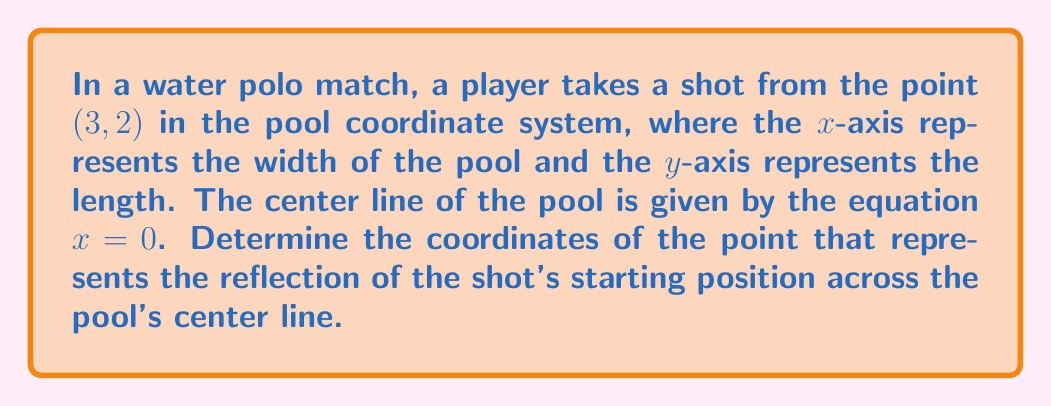What is the answer to this math problem? To solve this problem, we need to understand the concept of reflection across a vertical line. In this case, we're reflecting across the line x = 0, which is the y-axis or the center line of the pool.

When reflecting a point across the y-axis:
1. The y-coordinate remains unchanged.
2. The x-coordinate changes sign.

Given:
- Original point: (3, 2)
- Reflection line: x = 0 (y-axis)

Steps:
1. Keep the y-coordinate the same: 2
2. Change the sign of the x-coordinate: 3 becomes -3

Therefore, the reflection of the point (3, 2) across the line x = 0 is (-3, 2).

We can verify this geometrically:
- The original point and its reflection are equidistant from the y-axis.
- The line segment connecting the original point and its reflection is perpendicular to the y-axis.

[asy]
import geometry;

unitsize(1cm);

// Draw axes
draw((-5,0)--(5,0), arrow=Arrow);
draw((0,-1)--(0,4), arrow=Arrow);

// Label axes
label("x", (5,0), E);
label("y", (0,4), N);

// Draw and label original point
dot((3,2), red);
label("(3, 2)", (3,2), NE);

// Draw and label reflected point
dot((-3,2), blue);
label("(-3, 2)", (-3,2), NW);

// Draw dashed line connecting points
draw((3,2)--(-3,2), dashed);

// Label center line
label("Center line", (0,3), W);
[/asy]

This diagram illustrates the original point (3, 2) in red, its reflection (-3, 2) in blue, and the center line of the pool (x = 0).
Answer: The reflection of the shot's starting position (3, 2) across the pool's center line is $(-3, 2)$. 